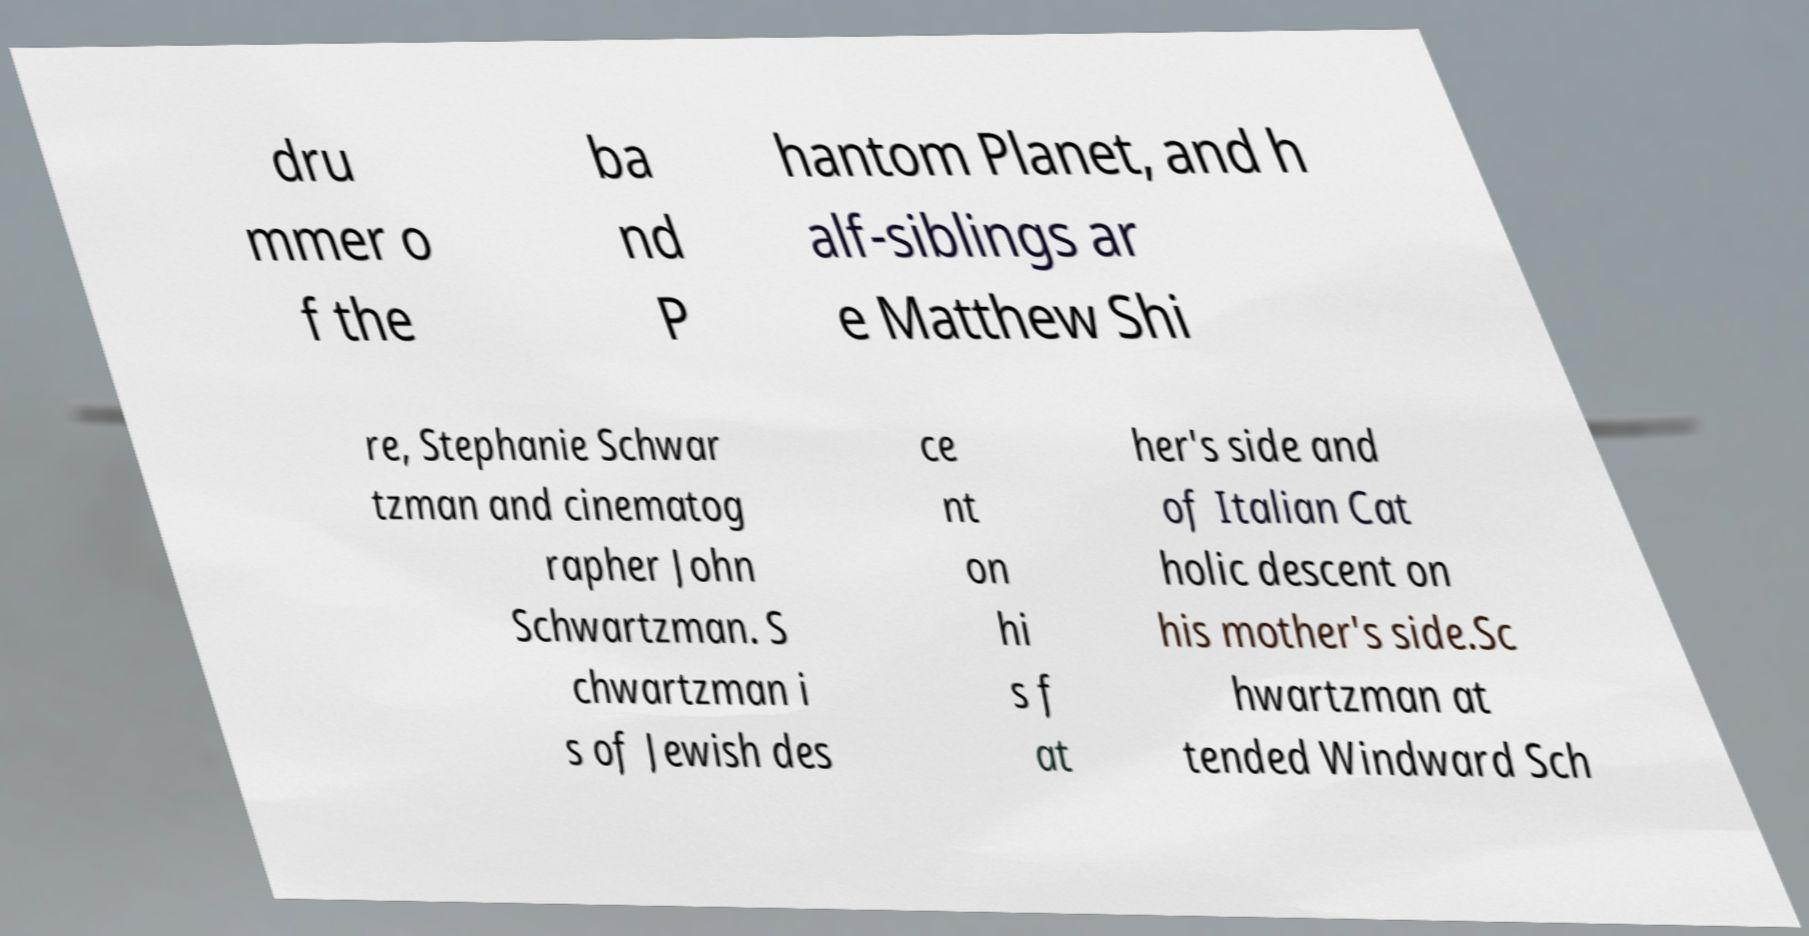Could you assist in decoding the text presented in this image and type it out clearly? dru mmer o f the ba nd P hantom Planet, and h alf-siblings ar e Matthew Shi re, Stephanie Schwar tzman and cinematog rapher John Schwartzman. S chwartzman i s of Jewish des ce nt on hi s f at her's side and of Italian Cat holic descent on his mother's side.Sc hwartzman at tended Windward Sch 